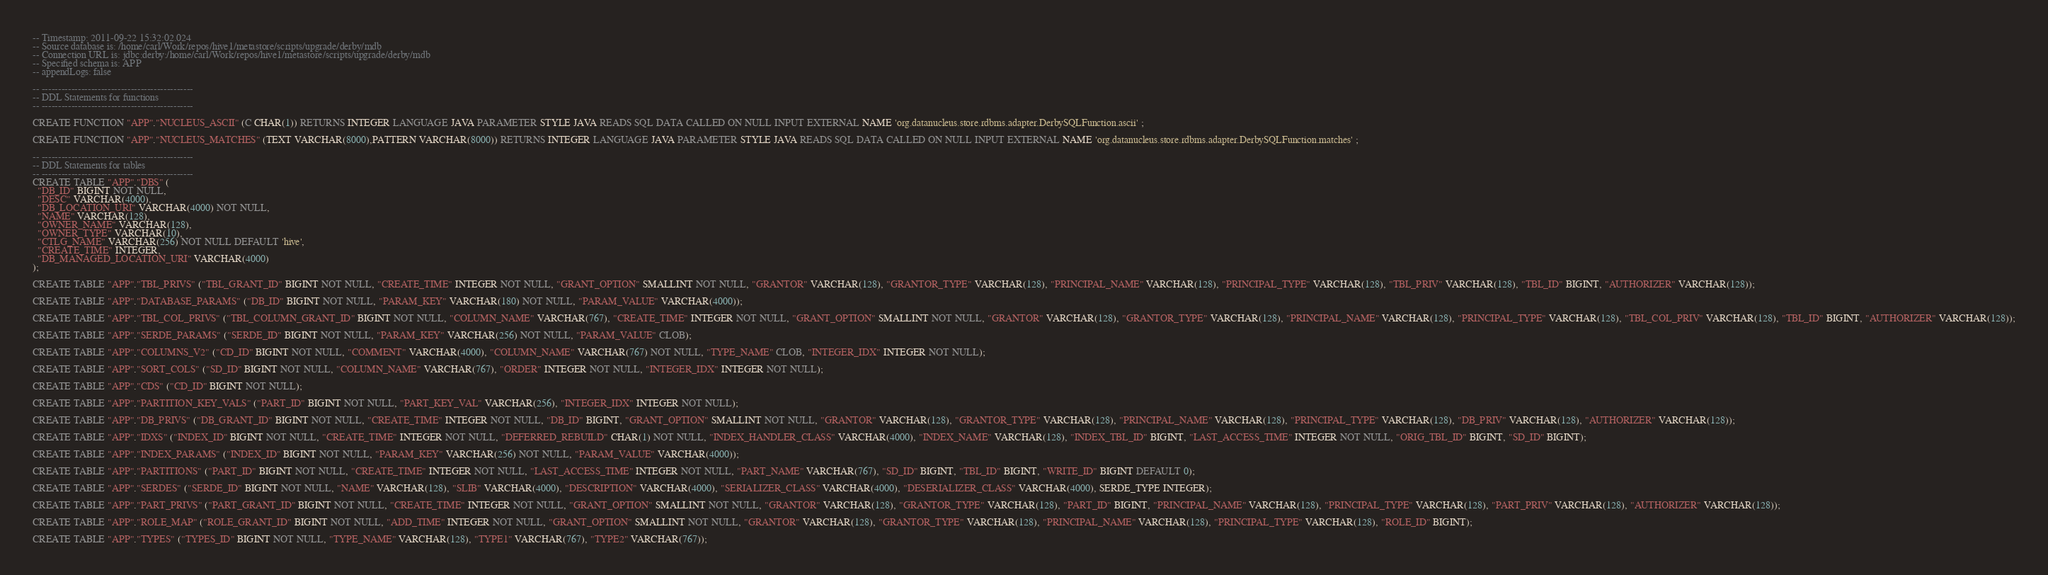Convert code to text. <code><loc_0><loc_0><loc_500><loc_500><_SQL_>-- Timestamp: 2011-09-22 15:32:02.024
-- Source database is: /home/carl/Work/repos/hive1/metastore/scripts/upgrade/derby/mdb
-- Connection URL is: jdbc:derby:/home/carl/Work/repos/hive1/metastore/scripts/upgrade/derby/mdb
-- Specified schema is: APP
-- appendLogs: false

-- ----------------------------------------------
-- DDL Statements for functions
-- ----------------------------------------------

CREATE FUNCTION "APP"."NUCLEUS_ASCII" (C CHAR(1)) RETURNS INTEGER LANGUAGE JAVA PARAMETER STYLE JAVA READS SQL DATA CALLED ON NULL INPUT EXTERNAL NAME 'org.datanucleus.store.rdbms.adapter.DerbySQLFunction.ascii' ;

CREATE FUNCTION "APP"."NUCLEUS_MATCHES" (TEXT VARCHAR(8000),PATTERN VARCHAR(8000)) RETURNS INTEGER LANGUAGE JAVA PARAMETER STYLE JAVA READS SQL DATA CALLED ON NULL INPUT EXTERNAL NAME 'org.datanucleus.store.rdbms.adapter.DerbySQLFunction.matches' ;

-- ----------------------------------------------
-- DDL Statements for tables
-- ----------------------------------------------
CREATE TABLE "APP"."DBS" (
  "DB_ID" BIGINT NOT NULL,
  "DESC" VARCHAR(4000),
  "DB_LOCATION_URI" VARCHAR(4000) NOT NULL,
  "NAME" VARCHAR(128),
  "OWNER_NAME" VARCHAR(128),
  "OWNER_TYPE" VARCHAR(10),
  "CTLG_NAME" VARCHAR(256) NOT NULL DEFAULT 'hive',
  "CREATE_TIME" INTEGER,
  "DB_MANAGED_LOCATION_URI" VARCHAR(4000)
);

CREATE TABLE "APP"."TBL_PRIVS" ("TBL_GRANT_ID" BIGINT NOT NULL, "CREATE_TIME" INTEGER NOT NULL, "GRANT_OPTION" SMALLINT NOT NULL, "GRANTOR" VARCHAR(128), "GRANTOR_TYPE" VARCHAR(128), "PRINCIPAL_NAME" VARCHAR(128), "PRINCIPAL_TYPE" VARCHAR(128), "TBL_PRIV" VARCHAR(128), "TBL_ID" BIGINT, "AUTHORIZER" VARCHAR(128));

CREATE TABLE "APP"."DATABASE_PARAMS" ("DB_ID" BIGINT NOT NULL, "PARAM_KEY" VARCHAR(180) NOT NULL, "PARAM_VALUE" VARCHAR(4000));

CREATE TABLE "APP"."TBL_COL_PRIVS" ("TBL_COLUMN_GRANT_ID" BIGINT NOT NULL, "COLUMN_NAME" VARCHAR(767), "CREATE_TIME" INTEGER NOT NULL, "GRANT_OPTION" SMALLINT NOT NULL, "GRANTOR" VARCHAR(128), "GRANTOR_TYPE" VARCHAR(128), "PRINCIPAL_NAME" VARCHAR(128), "PRINCIPAL_TYPE" VARCHAR(128), "TBL_COL_PRIV" VARCHAR(128), "TBL_ID" BIGINT, "AUTHORIZER" VARCHAR(128));

CREATE TABLE "APP"."SERDE_PARAMS" ("SERDE_ID" BIGINT NOT NULL, "PARAM_KEY" VARCHAR(256) NOT NULL, "PARAM_VALUE" CLOB);

CREATE TABLE "APP"."COLUMNS_V2" ("CD_ID" BIGINT NOT NULL, "COMMENT" VARCHAR(4000), "COLUMN_NAME" VARCHAR(767) NOT NULL, "TYPE_NAME" CLOB, "INTEGER_IDX" INTEGER NOT NULL);

CREATE TABLE "APP"."SORT_COLS" ("SD_ID" BIGINT NOT NULL, "COLUMN_NAME" VARCHAR(767), "ORDER" INTEGER NOT NULL, "INTEGER_IDX" INTEGER NOT NULL);

CREATE TABLE "APP"."CDS" ("CD_ID" BIGINT NOT NULL);

CREATE TABLE "APP"."PARTITION_KEY_VALS" ("PART_ID" BIGINT NOT NULL, "PART_KEY_VAL" VARCHAR(256), "INTEGER_IDX" INTEGER NOT NULL);

CREATE TABLE "APP"."DB_PRIVS" ("DB_GRANT_ID" BIGINT NOT NULL, "CREATE_TIME" INTEGER NOT NULL, "DB_ID" BIGINT, "GRANT_OPTION" SMALLINT NOT NULL, "GRANTOR" VARCHAR(128), "GRANTOR_TYPE" VARCHAR(128), "PRINCIPAL_NAME" VARCHAR(128), "PRINCIPAL_TYPE" VARCHAR(128), "DB_PRIV" VARCHAR(128), "AUTHORIZER" VARCHAR(128));

CREATE TABLE "APP"."IDXS" ("INDEX_ID" BIGINT NOT NULL, "CREATE_TIME" INTEGER NOT NULL, "DEFERRED_REBUILD" CHAR(1) NOT NULL, "INDEX_HANDLER_CLASS" VARCHAR(4000), "INDEX_NAME" VARCHAR(128), "INDEX_TBL_ID" BIGINT, "LAST_ACCESS_TIME" INTEGER NOT NULL, "ORIG_TBL_ID" BIGINT, "SD_ID" BIGINT);

CREATE TABLE "APP"."INDEX_PARAMS" ("INDEX_ID" BIGINT NOT NULL, "PARAM_KEY" VARCHAR(256) NOT NULL, "PARAM_VALUE" VARCHAR(4000));

CREATE TABLE "APP"."PARTITIONS" ("PART_ID" BIGINT NOT NULL, "CREATE_TIME" INTEGER NOT NULL, "LAST_ACCESS_TIME" INTEGER NOT NULL, "PART_NAME" VARCHAR(767), "SD_ID" BIGINT, "TBL_ID" BIGINT, "WRITE_ID" BIGINT DEFAULT 0);

CREATE TABLE "APP"."SERDES" ("SERDE_ID" BIGINT NOT NULL, "NAME" VARCHAR(128), "SLIB" VARCHAR(4000), "DESCRIPTION" VARCHAR(4000), "SERIALIZER_CLASS" VARCHAR(4000), "DESERIALIZER_CLASS" VARCHAR(4000), SERDE_TYPE INTEGER);

CREATE TABLE "APP"."PART_PRIVS" ("PART_GRANT_ID" BIGINT NOT NULL, "CREATE_TIME" INTEGER NOT NULL, "GRANT_OPTION" SMALLINT NOT NULL, "GRANTOR" VARCHAR(128), "GRANTOR_TYPE" VARCHAR(128), "PART_ID" BIGINT, "PRINCIPAL_NAME" VARCHAR(128), "PRINCIPAL_TYPE" VARCHAR(128), "PART_PRIV" VARCHAR(128), "AUTHORIZER" VARCHAR(128));

CREATE TABLE "APP"."ROLE_MAP" ("ROLE_GRANT_ID" BIGINT NOT NULL, "ADD_TIME" INTEGER NOT NULL, "GRANT_OPTION" SMALLINT NOT NULL, "GRANTOR" VARCHAR(128), "GRANTOR_TYPE" VARCHAR(128), "PRINCIPAL_NAME" VARCHAR(128), "PRINCIPAL_TYPE" VARCHAR(128), "ROLE_ID" BIGINT);

CREATE TABLE "APP"."TYPES" ("TYPES_ID" BIGINT NOT NULL, "TYPE_NAME" VARCHAR(128), "TYPE1" VARCHAR(767), "TYPE2" VARCHAR(767));
</code> 